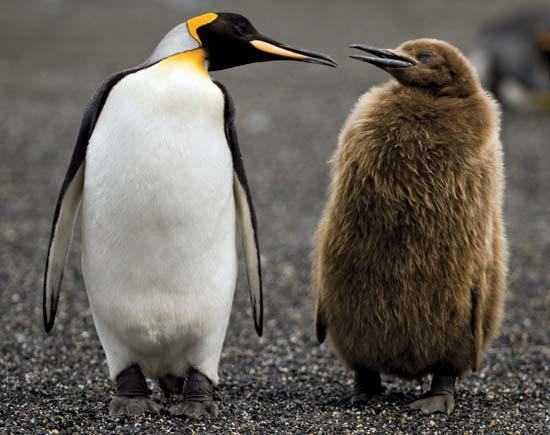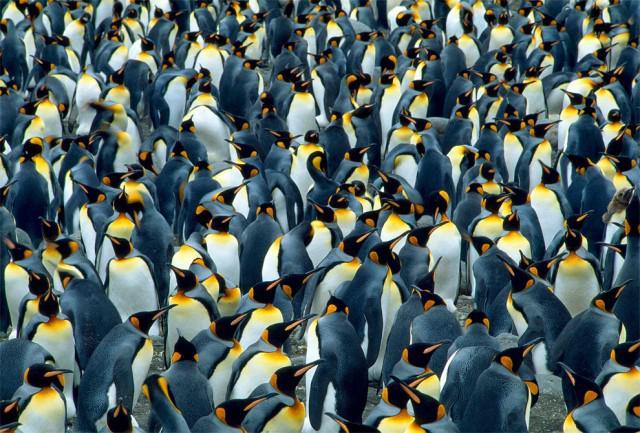The first image is the image on the left, the second image is the image on the right. Assess this claim about the two images: "There are two penguins in the left image". Correct or not? Answer yes or no. Yes. The first image is the image on the left, the second image is the image on the right. Evaluate the accuracy of this statement regarding the images: "One image shows just two penguins side-by-side, with faces turned inward.". Is it true? Answer yes or no. Yes. 